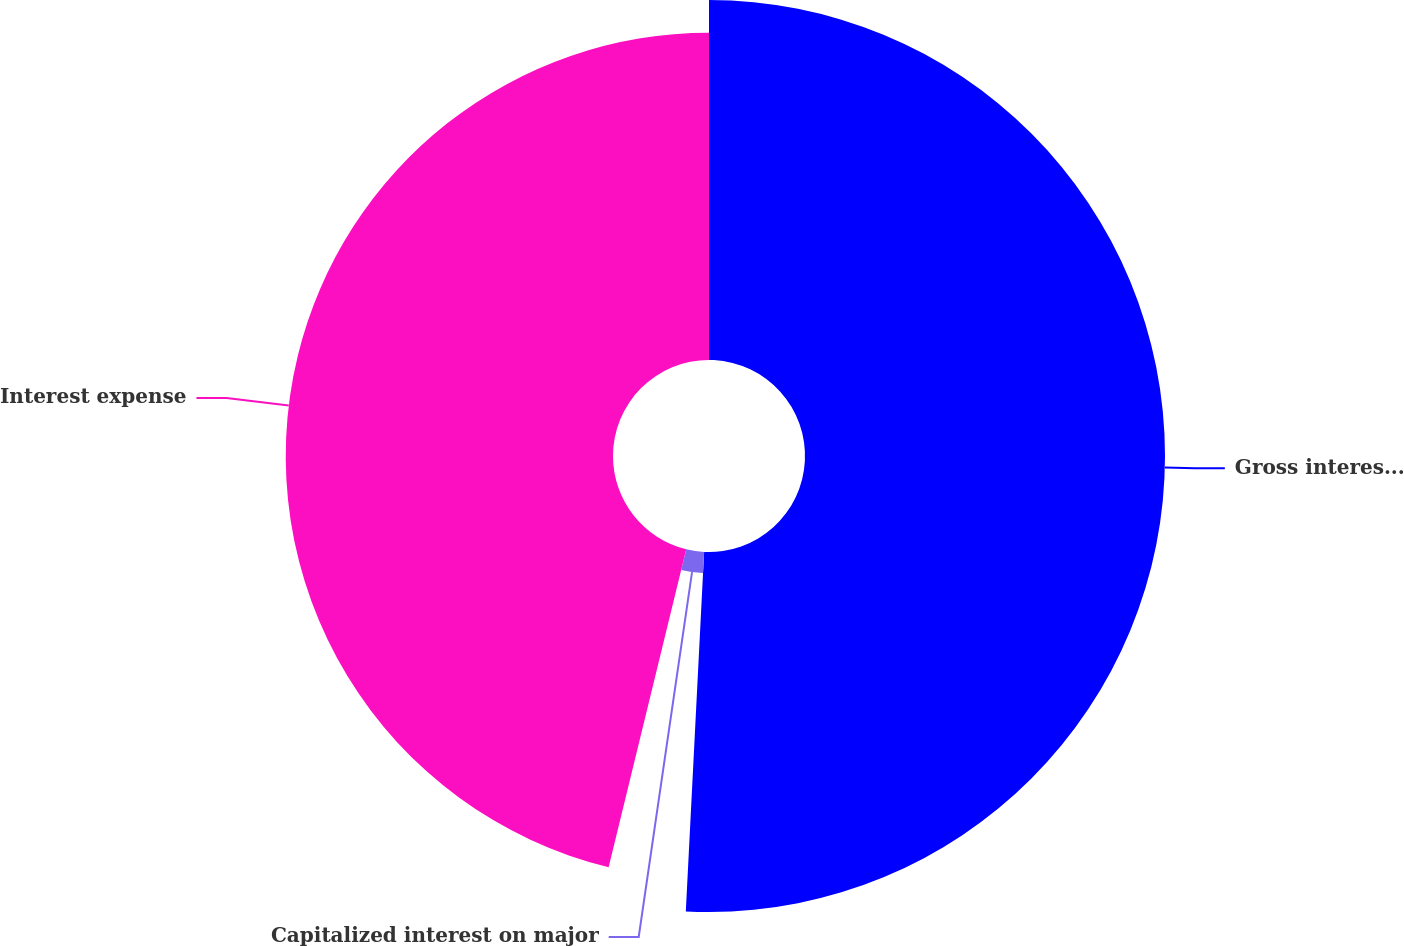<chart> <loc_0><loc_0><loc_500><loc_500><pie_chart><fcel>Gross interest cost<fcel>Capitalized interest on major<fcel>Interest expense<nl><fcel>50.81%<fcel>3.0%<fcel>46.19%<nl></chart> 